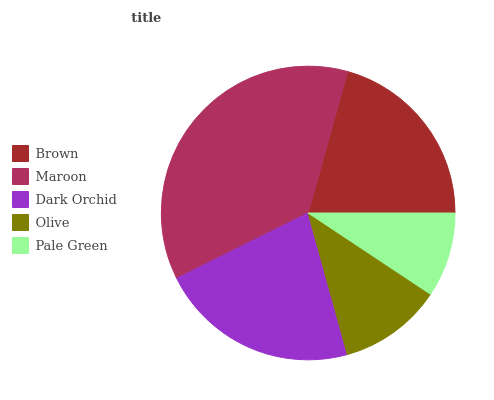Is Pale Green the minimum?
Answer yes or no. Yes. Is Maroon the maximum?
Answer yes or no. Yes. Is Dark Orchid the minimum?
Answer yes or no. No. Is Dark Orchid the maximum?
Answer yes or no. No. Is Maroon greater than Dark Orchid?
Answer yes or no. Yes. Is Dark Orchid less than Maroon?
Answer yes or no. Yes. Is Dark Orchid greater than Maroon?
Answer yes or no. No. Is Maroon less than Dark Orchid?
Answer yes or no. No. Is Brown the high median?
Answer yes or no. Yes. Is Brown the low median?
Answer yes or no. Yes. Is Maroon the high median?
Answer yes or no. No. Is Pale Green the low median?
Answer yes or no. No. 